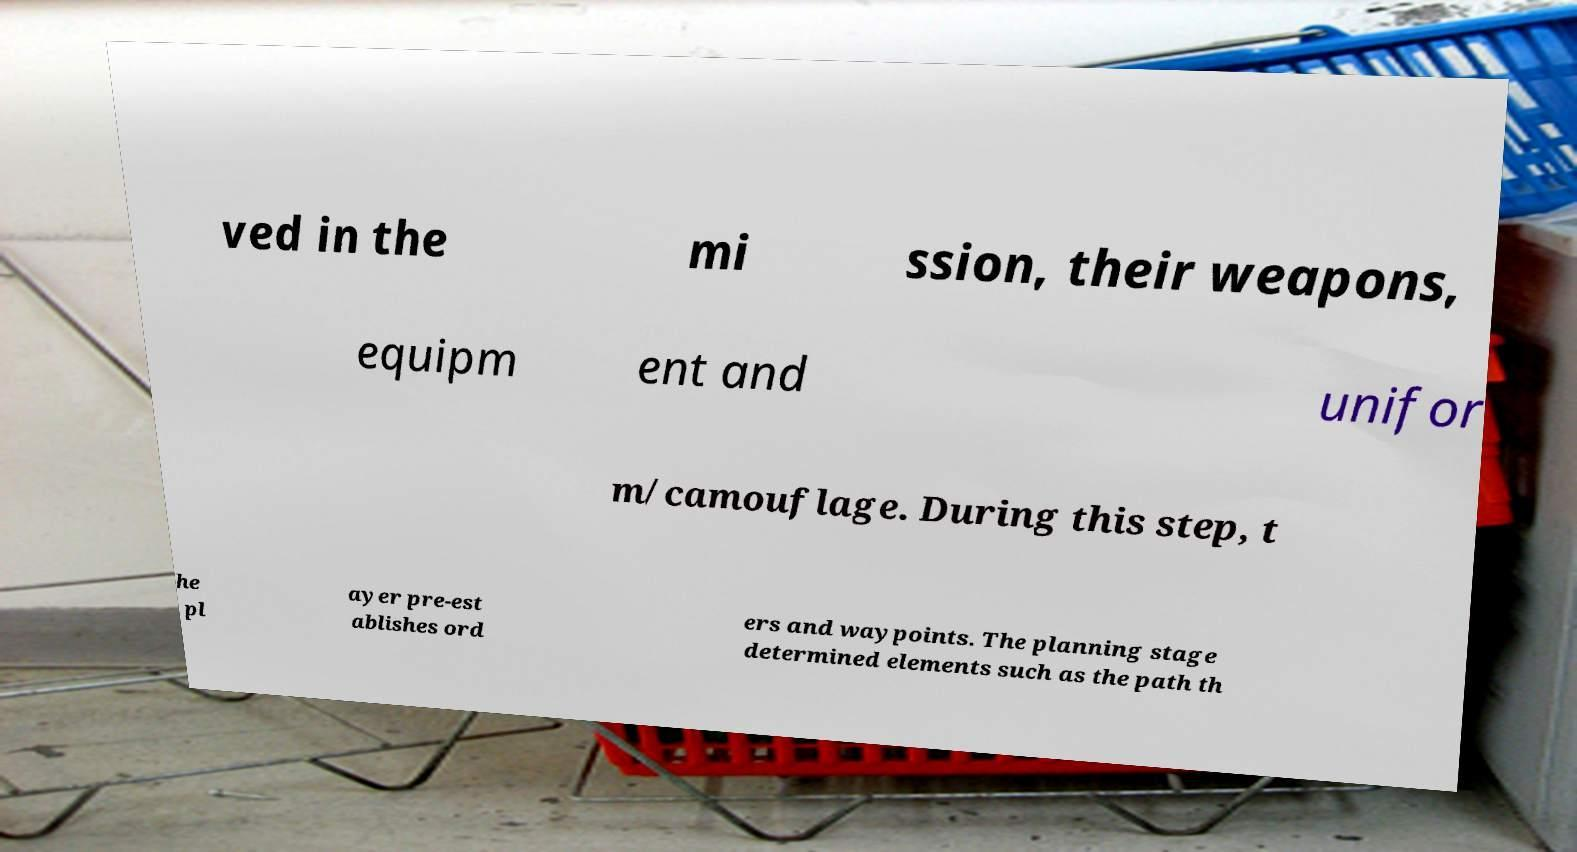Please read and relay the text visible in this image. What does it say? ved in the mi ssion, their weapons, equipm ent and unifor m/camouflage. During this step, t he pl ayer pre-est ablishes ord ers and waypoints. The planning stage determined elements such as the path th 